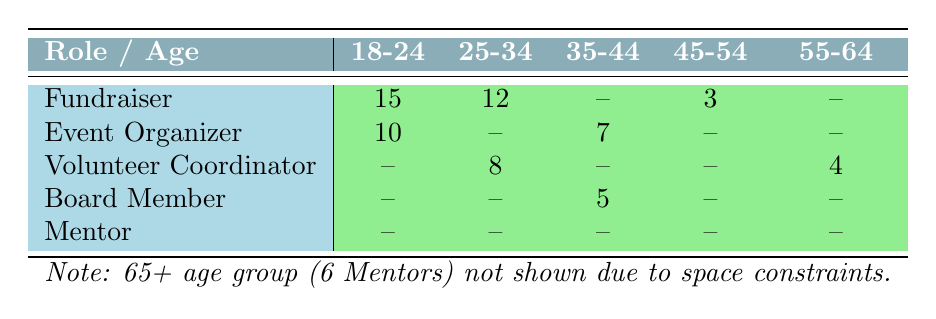What is the total number of participants in the 18-24 age group? The table lists two roles under the 18-24 age group: Fundraiser has 15 participants and Event Organizer has 10 participants. By adding these together, we get 15 + 10 = 25.
Answer: 25 How many participants are there in the 35-44 age group for the Event Organizer role? According to the table, there is 1 role listed under the 35-44 age group for Event Organizer, which has 7 participants.
Answer: 7 Is there any participant from the 45-54 age group for the Volunteer Coordinator role? The table indicates that there are no participants listed under the Volunteer Coordinator role for the 45-54 age group, as it shows a dash. Therefore, the answer is no.
Answer: No Which age group has the highest number of participants as Fundraisers? The Fundraiser role has 15 participants in the 18-24 age group and 12 participants in the 25-34 age group, while the other groups have either 3 or none. Thus, the highest number of participants as Fundraisers is in the 18-24 age group.
Answer: 18-24 What is the average number of participants per age group for the Volunteer Coordinator role? The Volunteer Coordinator role has participants listed for two age groups: 25-34 (8 participants) and 55-64 (4 participants). To find the average, add the two values: 8 + 4 = 12, then divide by 2 (the number of age groups) resulting in 12/2 = 6.
Answer: 6 In total, how many participants are involved in roles other than Fundraiser in the 25-34 age group? In the 25-34 age group, the only role other than Fundraiser is Volunteer Coordinator, which has 8 participants. Therefore, the total involved in roles other than Fundraiser is 8.
Answer: 8 Is it true that there are more participants in the 65+ age group than in the 45-54 age group? The table indicates 6 participants in the 65+ age group (Mentors) while the 45-54 age group has only 3 as Fundraisers. Since 6 > 3, the statement is true.
Answer: Yes How many total roles are listed for the 55-64 age group and what is the number of participants in those roles? The 55-64 age group has two roles listed: Volunteer Coordinator (4 participants) and no roles for Event Organizer or Board Member. Therefore, total roles are 1 and total participants are 4.
Answer: 1 role, 4 participants 